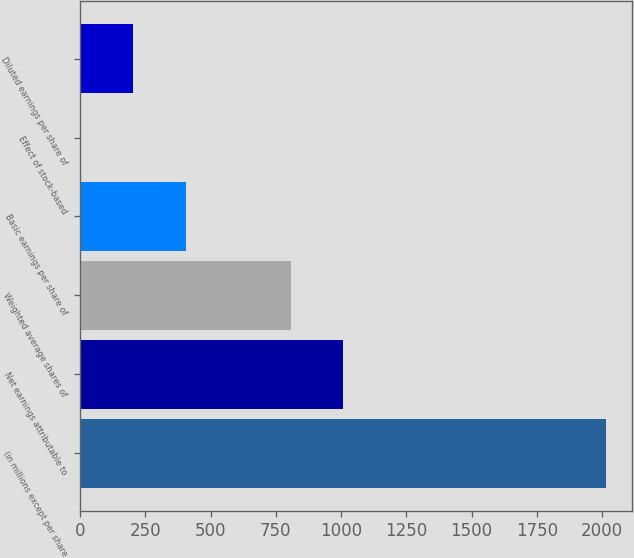Convert chart. <chart><loc_0><loc_0><loc_500><loc_500><bar_chart><fcel>(in millions except per share<fcel>Net earnings attributable to<fcel>Weighted average shares of<fcel>Basic earnings per share of<fcel>Effect of stock-based<fcel>Diluted earnings per share of<nl><fcel>2015<fcel>1008.13<fcel>806.75<fcel>403.99<fcel>1.23<fcel>202.61<nl></chart> 